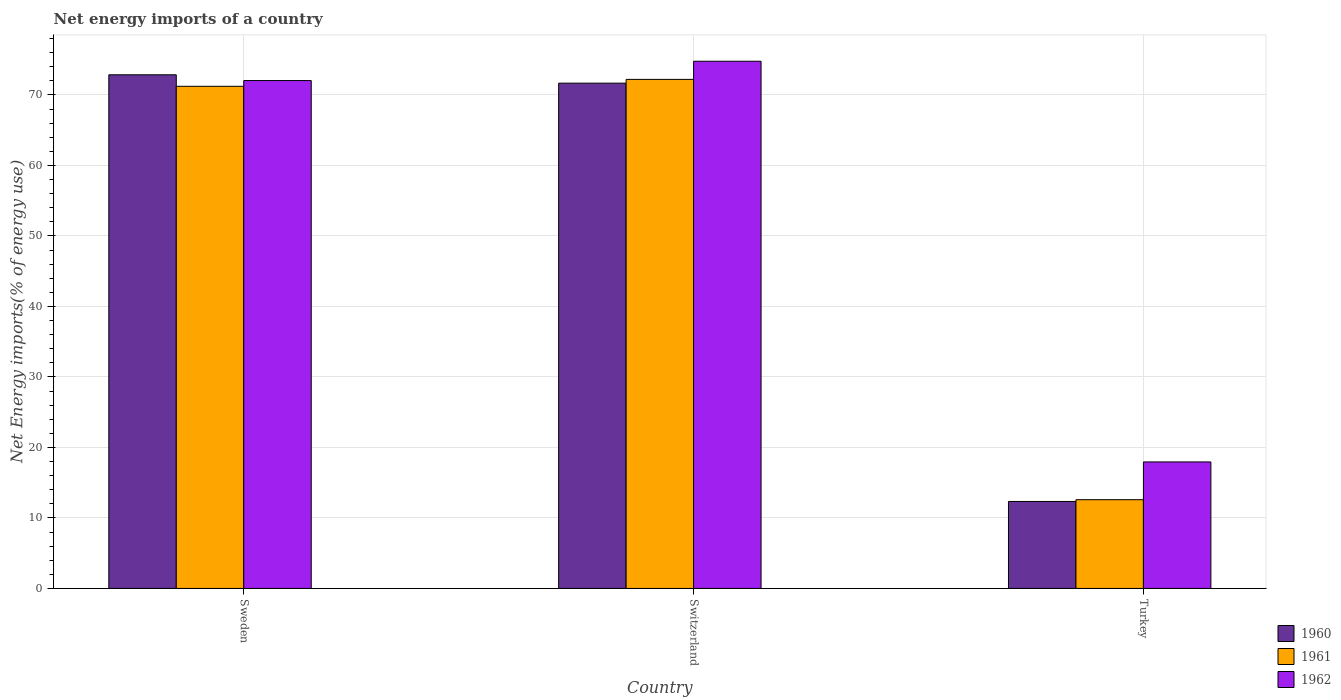Are the number of bars per tick equal to the number of legend labels?
Make the answer very short. Yes. How many bars are there on the 1st tick from the right?
Provide a succinct answer. 3. What is the label of the 1st group of bars from the left?
Offer a very short reply. Sweden. What is the net energy imports in 1961 in Turkey?
Your response must be concise. 12.59. Across all countries, what is the maximum net energy imports in 1960?
Keep it short and to the point. 72.86. Across all countries, what is the minimum net energy imports in 1960?
Give a very brief answer. 12.34. In which country was the net energy imports in 1962 maximum?
Offer a terse response. Switzerland. In which country was the net energy imports in 1961 minimum?
Your answer should be compact. Turkey. What is the total net energy imports in 1961 in the graph?
Offer a very short reply. 156.02. What is the difference between the net energy imports in 1960 in Sweden and that in Turkey?
Your answer should be very brief. 60.52. What is the difference between the net energy imports in 1960 in Sweden and the net energy imports in 1962 in Turkey?
Offer a very short reply. 54.92. What is the average net energy imports in 1961 per country?
Give a very brief answer. 52.01. What is the difference between the net energy imports of/in 1960 and net energy imports of/in 1961 in Turkey?
Your answer should be very brief. -0.25. In how many countries, is the net energy imports in 1961 greater than 60 %?
Provide a succinct answer. 2. What is the ratio of the net energy imports in 1962 in Sweden to that in Turkey?
Your response must be concise. 4.02. Is the net energy imports in 1961 in Sweden less than that in Switzerland?
Provide a succinct answer. Yes. What is the difference between the highest and the second highest net energy imports in 1962?
Offer a terse response. 54.1. What is the difference between the highest and the lowest net energy imports in 1961?
Give a very brief answer. 59.62. What does the 1st bar from the left in Turkey represents?
Offer a very short reply. 1960. What does the 3rd bar from the right in Turkey represents?
Ensure brevity in your answer.  1960. Is it the case that in every country, the sum of the net energy imports in 1962 and net energy imports in 1960 is greater than the net energy imports in 1961?
Offer a terse response. Yes. How many countries are there in the graph?
Offer a very short reply. 3. Where does the legend appear in the graph?
Offer a very short reply. Bottom right. How many legend labels are there?
Provide a succinct answer. 3. What is the title of the graph?
Your answer should be very brief. Net energy imports of a country. Does "1985" appear as one of the legend labels in the graph?
Keep it short and to the point. No. What is the label or title of the Y-axis?
Offer a very short reply. Net Energy imports(% of energy use). What is the Net Energy imports(% of energy use) of 1960 in Sweden?
Ensure brevity in your answer.  72.86. What is the Net Energy imports(% of energy use) of 1961 in Sweden?
Offer a terse response. 71.22. What is the Net Energy imports(% of energy use) in 1962 in Sweden?
Your answer should be very brief. 72.04. What is the Net Energy imports(% of energy use) of 1960 in Switzerland?
Your answer should be very brief. 71.67. What is the Net Energy imports(% of energy use) in 1961 in Switzerland?
Ensure brevity in your answer.  72.21. What is the Net Energy imports(% of energy use) of 1962 in Switzerland?
Keep it short and to the point. 74.78. What is the Net Energy imports(% of energy use) of 1960 in Turkey?
Make the answer very short. 12.34. What is the Net Energy imports(% of energy use) of 1961 in Turkey?
Your response must be concise. 12.59. What is the Net Energy imports(% of energy use) of 1962 in Turkey?
Provide a short and direct response. 17.94. Across all countries, what is the maximum Net Energy imports(% of energy use) in 1960?
Ensure brevity in your answer.  72.86. Across all countries, what is the maximum Net Energy imports(% of energy use) in 1961?
Ensure brevity in your answer.  72.21. Across all countries, what is the maximum Net Energy imports(% of energy use) in 1962?
Give a very brief answer. 74.78. Across all countries, what is the minimum Net Energy imports(% of energy use) in 1960?
Offer a very short reply. 12.34. Across all countries, what is the minimum Net Energy imports(% of energy use) of 1961?
Provide a short and direct response. 12.59. Across all countries, what is the minimum Net Energy imports(% of energy use) in 1962?
Your answer should be very brief. 17.94. What is the total Net Energy imports(% of energy use) in 1960 in the graph?
Ensure brevity in your answer.  156.86. What is the total Net Energy imports(% of energy use) of 1961 in the graph?
Your response must be concise. 156.02. What is the total Net Energy imports(% of energy use) of 1962 in the graph?
Make the answer very short. 164.76. What is the difference between the Net Energy imports(% of energy use) in 1960 in Sweden and that in Switzerland?
Give a very brief answer. 1.19. What is the difference between the Net Energy imports(% of energy use) in 1961 in Sweden and that in Switzerland?
Offer a very short reply. -0.98. What is the difference between the Net Energy imports(% of energy use) in 1962 in Sweden and that in Switzerland?
Make the answer very short. -2.74. What is the difference between the Net Energy imports(% of energy use) in 1960 in Sweden and that in Turkey?
Your answer should be very brief. 60.52. What is the difference between the Net Energy imports(% of energy use) in 1961 in Sweden and that in Turkey?
Provide a short and direct response. 58.64. What is the difference between the Net Energy imports(% of energy use) in 1962 in Sweden and that in Turkey?
Your answer should be compact. 54.1. What is the difference between the Net Energy imports(% of energy use) in 1960 in Switzerland and that in Turkey?
Give a very brief answer. 59.33. What is the difference between the Net Energy imports(% of energy use) in 1961 in Switzerland and that in Turkey?
Give a very brief answer. 59.62. What is the difference between the Net Energy imports(% of energy use) in 1962 in Switzerland and that in Turkey?
Provide a short and direct response. 56.84. What is the difference between the Net Energy imports(% of energy use) of 1960 in Sweden and the Net Energy imports(% of energy use) of 1961 in Switzerland?
Your response must be concise. 0.65. What is the difference between the Net Energy imports(% of energy use) in 1960 in Sweden and the Net Energy imports(% of energy use) in 1962 in Switzerland?
Provide a succinct answer. -1.92. What is the difference between the Net Energy imports(% of energy use) in 1961 in Sweden and the Net Energy imports(% of energy use) in 1962 in Switzerland?
Make the answer very short. -3.56. What is the difference between the Net Energy imports(% of energy use) of 1960 in Sweden and the Net Energy imports(% of energy use) of 1961 in Turkey?
Make the answer very short. 60.27. What is the difference between the Net Energy imports(% of energy use) of 1960 in Sweden and the Net Energy imports(% of energy use) of 1962 in Turkey?
Offer a very short reply. 54.92. What is the difference between the Net Energy imports(% of energy use) of 1961 in Sweden and the Net Energy imports(% of energy use) of 1962 in Turkey?
Give a very brief answer. 53.28. What is the difference between the Net Energy imports(% of energy use) of 1960 in Switzerland and the Net Energy imports(% of energy use) of 1961 in Turkey?
Offer a very short reply. 59.08. What is the difference between the Net Energy imports(% of energy use) in 1960 in Switzerland and the Net Energy imports(% of energy use) in 1962 in Turkey?
Your answer should be very brief. 53.73. What is the difference between the Net Energy imports(% of energy use) of 1961 in Switzerland and the Net Energy imports(% of energy use) of 1962 in Turkey?
Provide a short and direct response. 54.26. What is the average Net Energy imports(% of energy use) in 1960 per country?
Provide a succinct answer. 52.29. What is the average Net Energy imports(% of energy use) in 1961 per country?
Provide a succinct answer. 52.01. What is the average Net Energy imports(% of energy use) of 1962 per country?
Your answer should be very brief. 54.92. What is the difference between the Net Energy imports(% of energy use) in 1960 and Net Energy imports(% of energy use) in 1961 in Sweden?
Offer a very short reply. 1.63. What is the difference between the Net Energy imports(% of energy use) in 1960 and Net Energy imports(% of energy use) in 1962 in Sweden?
Keep it short and to the point. 0.82. What is the difference between the Net Energy imports(% of energy use) in 1961 and Net Energy imports(% of energy use) in 1962 in Sweden?
Offer a terse response. -0.81. What is the difference between the Net Energy imports(% of energy use) in 1960 and Net Energy imports(% of energy use) in 1961 in Switzerland?
Your answer should be very brief. -0.54. What is the difference between the Net Energy imports(% of energy use) in 1960 and Net Energy imports(% of energy use) in 1962 in Switzerland?
Give a very brief answer. -3.11. What is the difference between the Net Energy imports(% of energy use) of 1961 and Net Energy imports(% of energy use) of 1962 in Switzerland?
Provide a short and direct response. -2.57. What is the difference between the Net Energy imports(% of energy use) of 1960 and Net Energy imports(% of energy use) of 1961 in Turkey?
Your answer should be compact. -0.25. What is the difference between the Net Energy imports(% of energy use) in 1960 and Net Energy imports(% of energy use) in 1962 in Turkey?
Offer a terse response. -5.61. What is the difference between the Net Energy imports(% of energy use) in 1961 and Net Energy imports(% of energy use) in 1962 in Turkey?
Give a very brief answer. -5.36. What is the ratio of the Net Energy imports(% of energy use) in 1960 in Sweden to that in Switzerland?
Your answer should be very brief. 1.02. What is the ratio of the Net Energy imports(% of energy use) in 1961 in Sweden to that in Switzerland?
Your response must be concise. 0.99. What is the ratio of the Net Energy imports(% of energy use) in 1962 in Sweden to that in Switzerland?
Keep it short and to the point. 0.96. What is the ratio of the Net Energy imports(% of energy use) in 1960 in Sweden to that in Turkey?
Your response must be concise. 5.91. What is the ratio of the Net Energy imports(% of energy use) in 1961 in Sweden to that in Turkey?
Your answer should be compact. 5.66. What is the ratio of the Net Energy imports(% of energy use) of 1962 in Sweden to that in Turkey?
Your answer should be compact. 4.02. What is the ratio of the Net Energy imports(% of energy use) of 1960 in Switzerland to that in Turkey?
Keep it short and to the point. 5.81. What is the ratio of the Net Energy imports(% of energy use) in 1961 in Switzerland to that in Turkey?
Keep it short and to the point. 5.74. What is the ratio of the Net Energy imports(% of energy use) of 1962 in Switzerland to that in Turkey?
Ensure brevity in your answer.  4.17. What is the difference between the highest and the second highest Net Energy imports(% of energy use) in 1960?
Give a very brief answer. 1.19. What is the difference between the highest and the second highest Net Energy imports(% of energy use) in 1961?
Your answer should be very brief. 0.98. What is the difference between the highest and the second highest Net Energy imports(% of energy use) in 1962?
Keep it short and to the point. 2.74. What is the difference between the highest and the lowest Net Energy imports(% of energy use) of 1960?
Offer a very short reply. 60.52. What is the difference between the highest and the lowest Net Energy imports(% of energy use) in 1961?
Your answer should be compact. 59.62. What is the difference between the highest and the lowest Net Energy imports(% of energy use) of 1962?
Offer a very short reply. 56.84. 